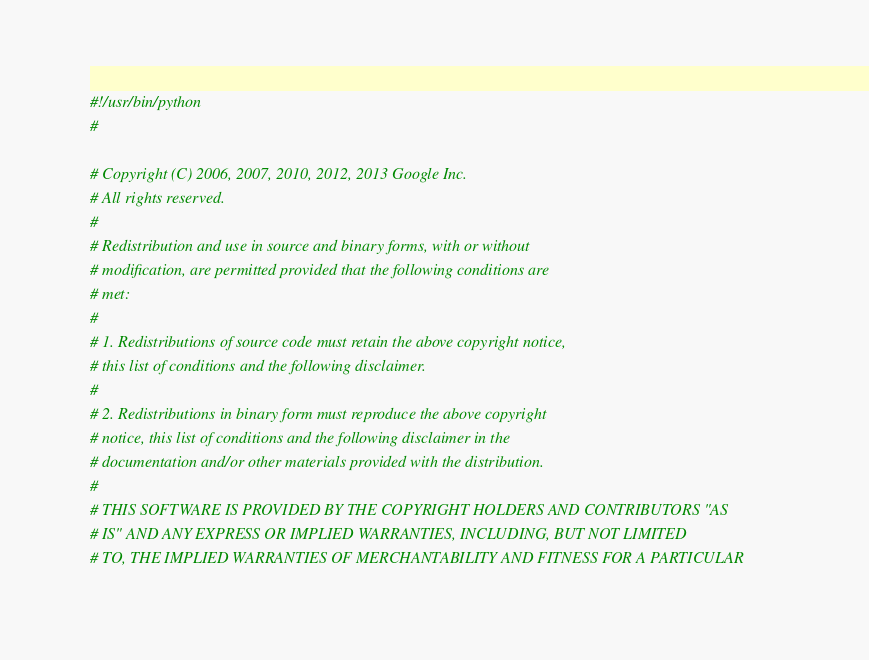<code> <loc_0><loc_0><loc_500><loc_500><_Python_>#!/usr/bin/python
#

# Copyright (C) 2006, 2007, 2010, 2012, 2013 Google Inc.
# All rights reserved.
#
# Redistribution and use in source and binary forms, with or without
# modification, are permitted provided that the following conditions are
# met:
#
# 1. Redistributions of source code must retain the above copyright notice,
# this list of conditions and the following disclaimer.
#
# 2. Redistributions in binary form must reproduce the above copyright
# notice, this list of conditions and the following disclaimer in the
# documentation and/or other materials provided with the distribution.
#
# THIS SOFTWARE IS PROVIDED BY THE COPYRIGHT HOLDERS AND CONTRIBUTORS "AS
# IS" AND ANY EXPRESS OR IMPLIED WARRANTIES, INCLUDING, BUT NOT LIMITED
# TO, THE IMPLIED WARRANTIES OF MERCHANTABILITY AND FITNESS FOR A PARTICULAR</code> 